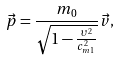Convert formula to latex. <formula><loc_0><loc_0><loc_500><loc_500>\vec { p } = \frac { m _ { 0 } } { \sqrt { 1 - \frac { \upsilon ^ { 2 } } { c _ { m 1 } ^ { 2 } } } } \vec { v } ,</formula> 